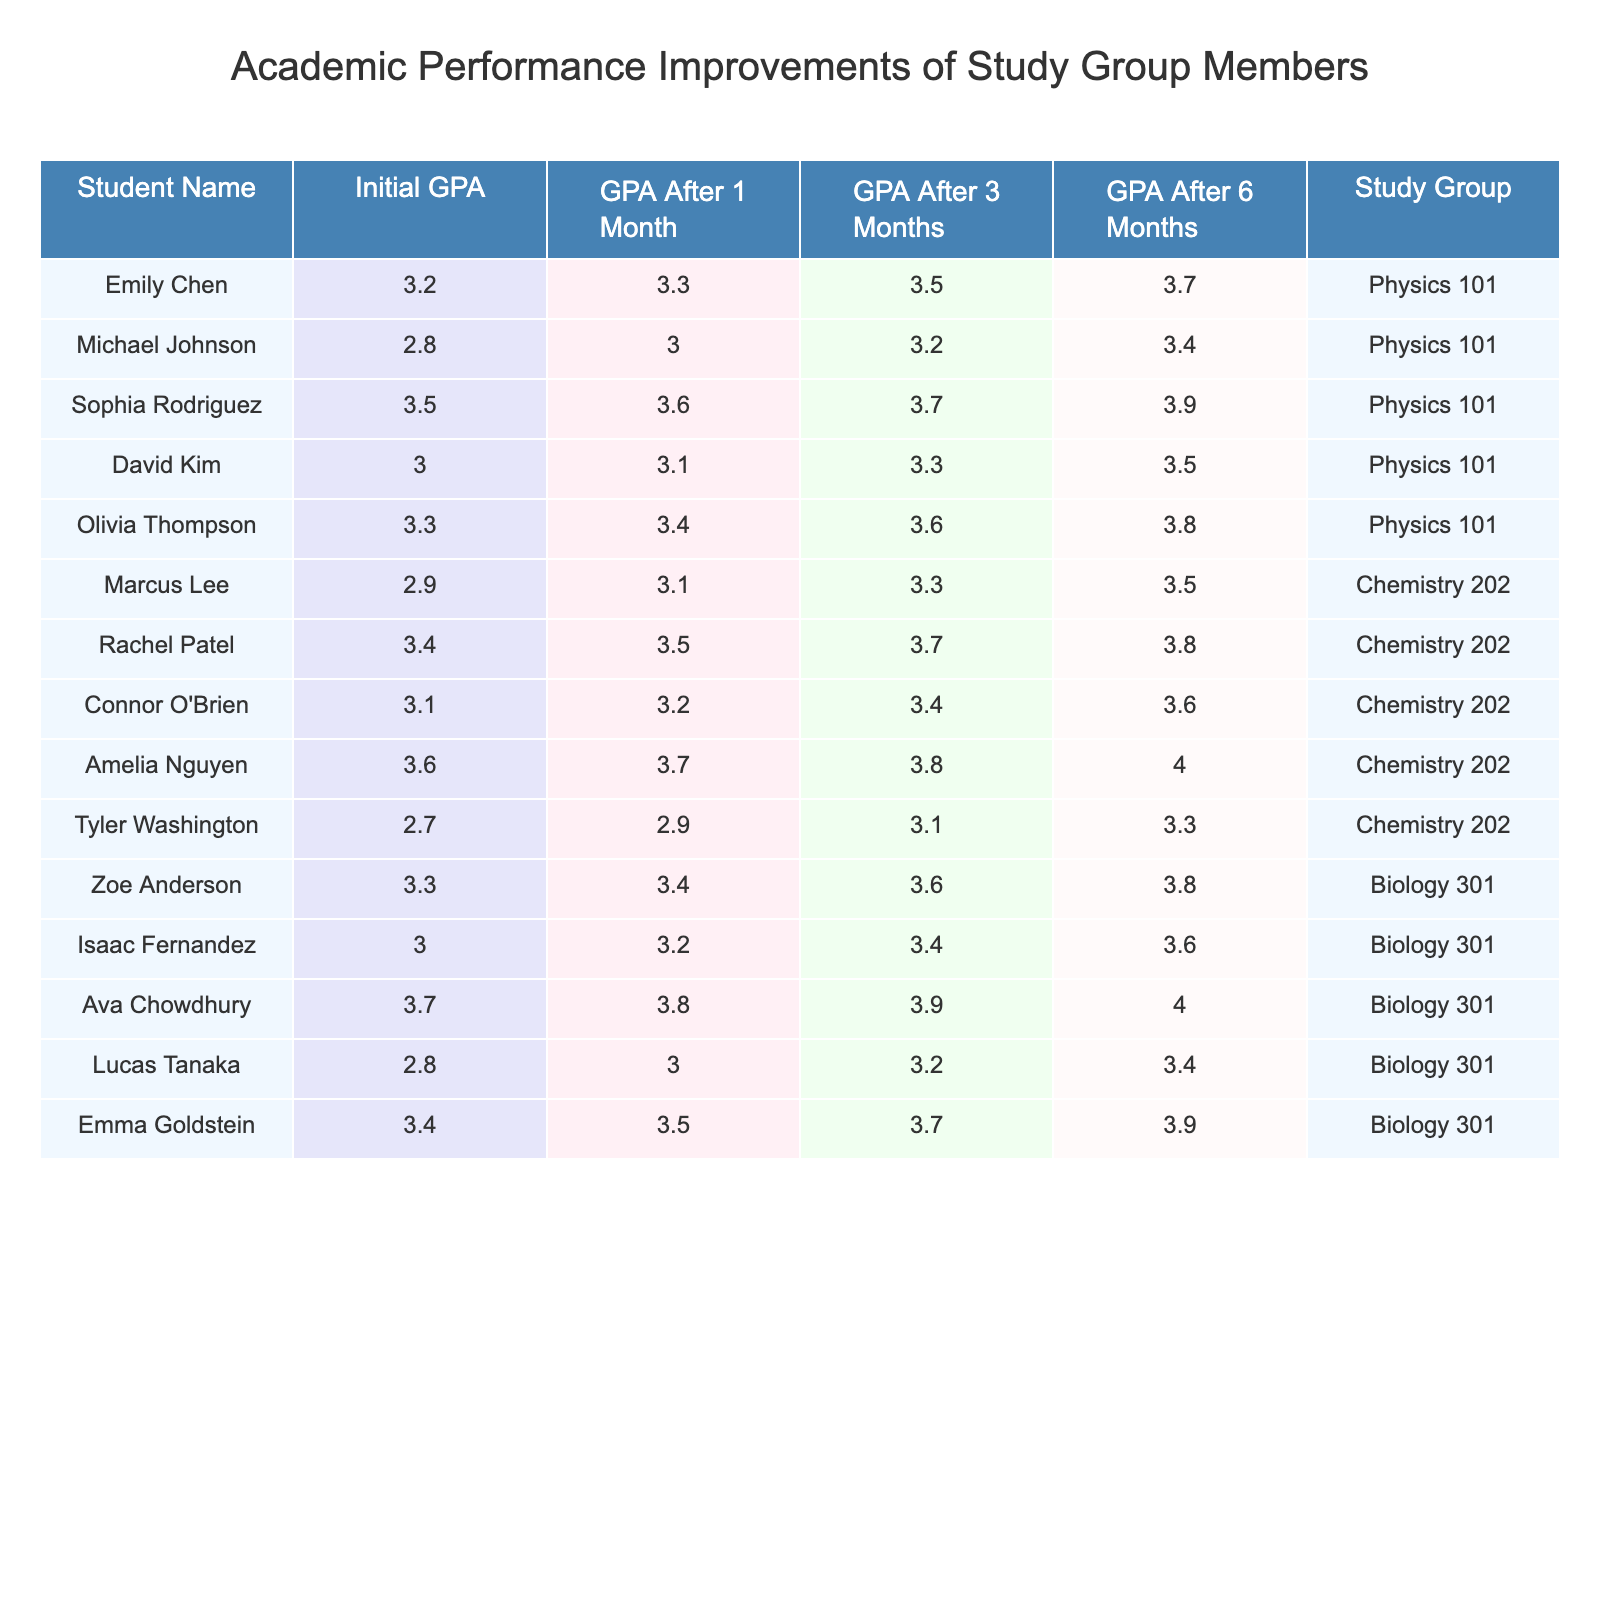What is the highest GPA achieved after 6 months among the study group members? By scanning the table under the "GPA After 6 Months" column, the highest value is 4.0, which corresponds to Amelia Nguyen and Ava Chowdhury.
Answer: 4.0 Which student had the lowest initial GPA in the table? Looking at the "Initial GPA" column, the lowest value is 2.7, which corresponds to Tyler Washington.
Answer: Tyler Washington What is the average GPA of students in the Physics 101 group after 3 months? The GPAs after 3 months for Physics 101 are: 3.3, 3.0, 3.6, 3.1, and 3.4. Adding these gives 16.4, and dividing by 5 (the number of students) gives an average of 3.28.
Answer: 3.28 Did any student maintain a GPA consistently above 3.5 at all time points (Initial, After 1 Month, After 3 Months, After 6 Months)? Checking each student's GPA at all time points for the mentioned criteria, Ava Chowdhury starts at 3.7 and continues to be above 3.5 in every subsequent measure.
Answer: Yes What is the difference in GPA after 6 months between the highest achieving and lowest achieving student in the Chemistry 202 group? In the Chemistry 202 group, Amelia Nguyen achieved a GPA of 4.0 after 6 months, while Tyler Washington achieved 3.3. The difference is 4.0 - 3.3 = 0.7.
Answer: 0.7 Which study group had the highest average GPA after 1 month? The average GPAs after 1 month for each group are: Physics 101 (3.3), Chemistry 202 (3.1), and Biology 301 (3.5). Comparing these averages, Biology 301 has the highest average.
Answer: Biology 301 How much did Michael Johnson's GPA improve after 6 months compared to his initial GPA? Michael Johnson had an initial GPA of 2.8 and a GPA after 6 months of 3.4. The improvement is 3.4 - 2.8 = 0.6.
Answer: 0.6 What percentage of students in the Biology 301 group achieved a GPA of 3.5 or higher after 6 months? The Biology 301 group has 5 students, and 3 of them (Ava Chowdhury, Emma Goldstein, and Zoe Anderson) achieved a GPA of 3.5 or higher after 6 months. The percentage is (3/5) * 100 = 60%.
Answer: 60% Is there any student in Chemistry 202 who improved their GPA by more than 1 point after 6 months? The students in Chemistry 202 had the following initial and final GPAs: Marcus Lee (2.9 to 3.5, 0.6), Rachel Patel (3.4 to 3.8, 0.4), Connor O'Brien (3.1 to 3.6, 0.5), and Amelia Nguyen (3.6 to 4.0, 0.4). None improved by more than 1 point.
Answer: No What is the total GPA improvement for Sophia Rodriguez from her initial GPA to after 6 months? Sophia Rodriguez had an initial GPA of 3.5 and a GPA after 6 months of 3.9. The total improvement is 3.9 - 3.5 = 0.4.
Answer: 0.4 